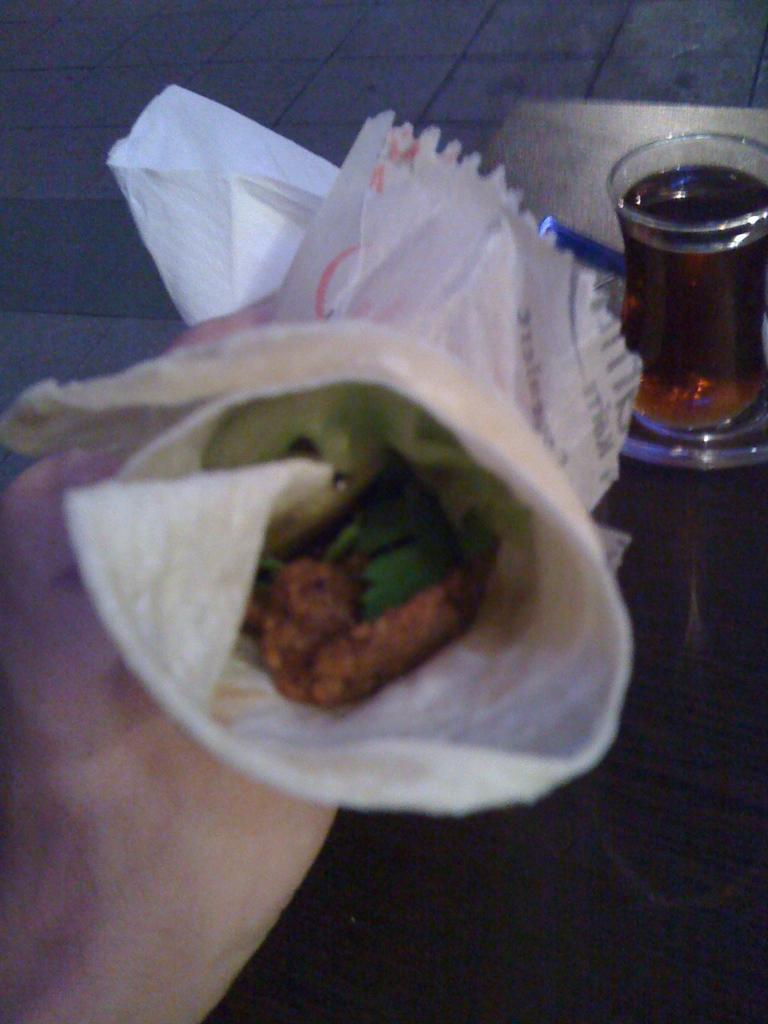In one or two sentences, can you explain what this image depicts? In this image we can see a person holding food roll wrapped in the paper napkin and a glass tumbler with beverage in it. 